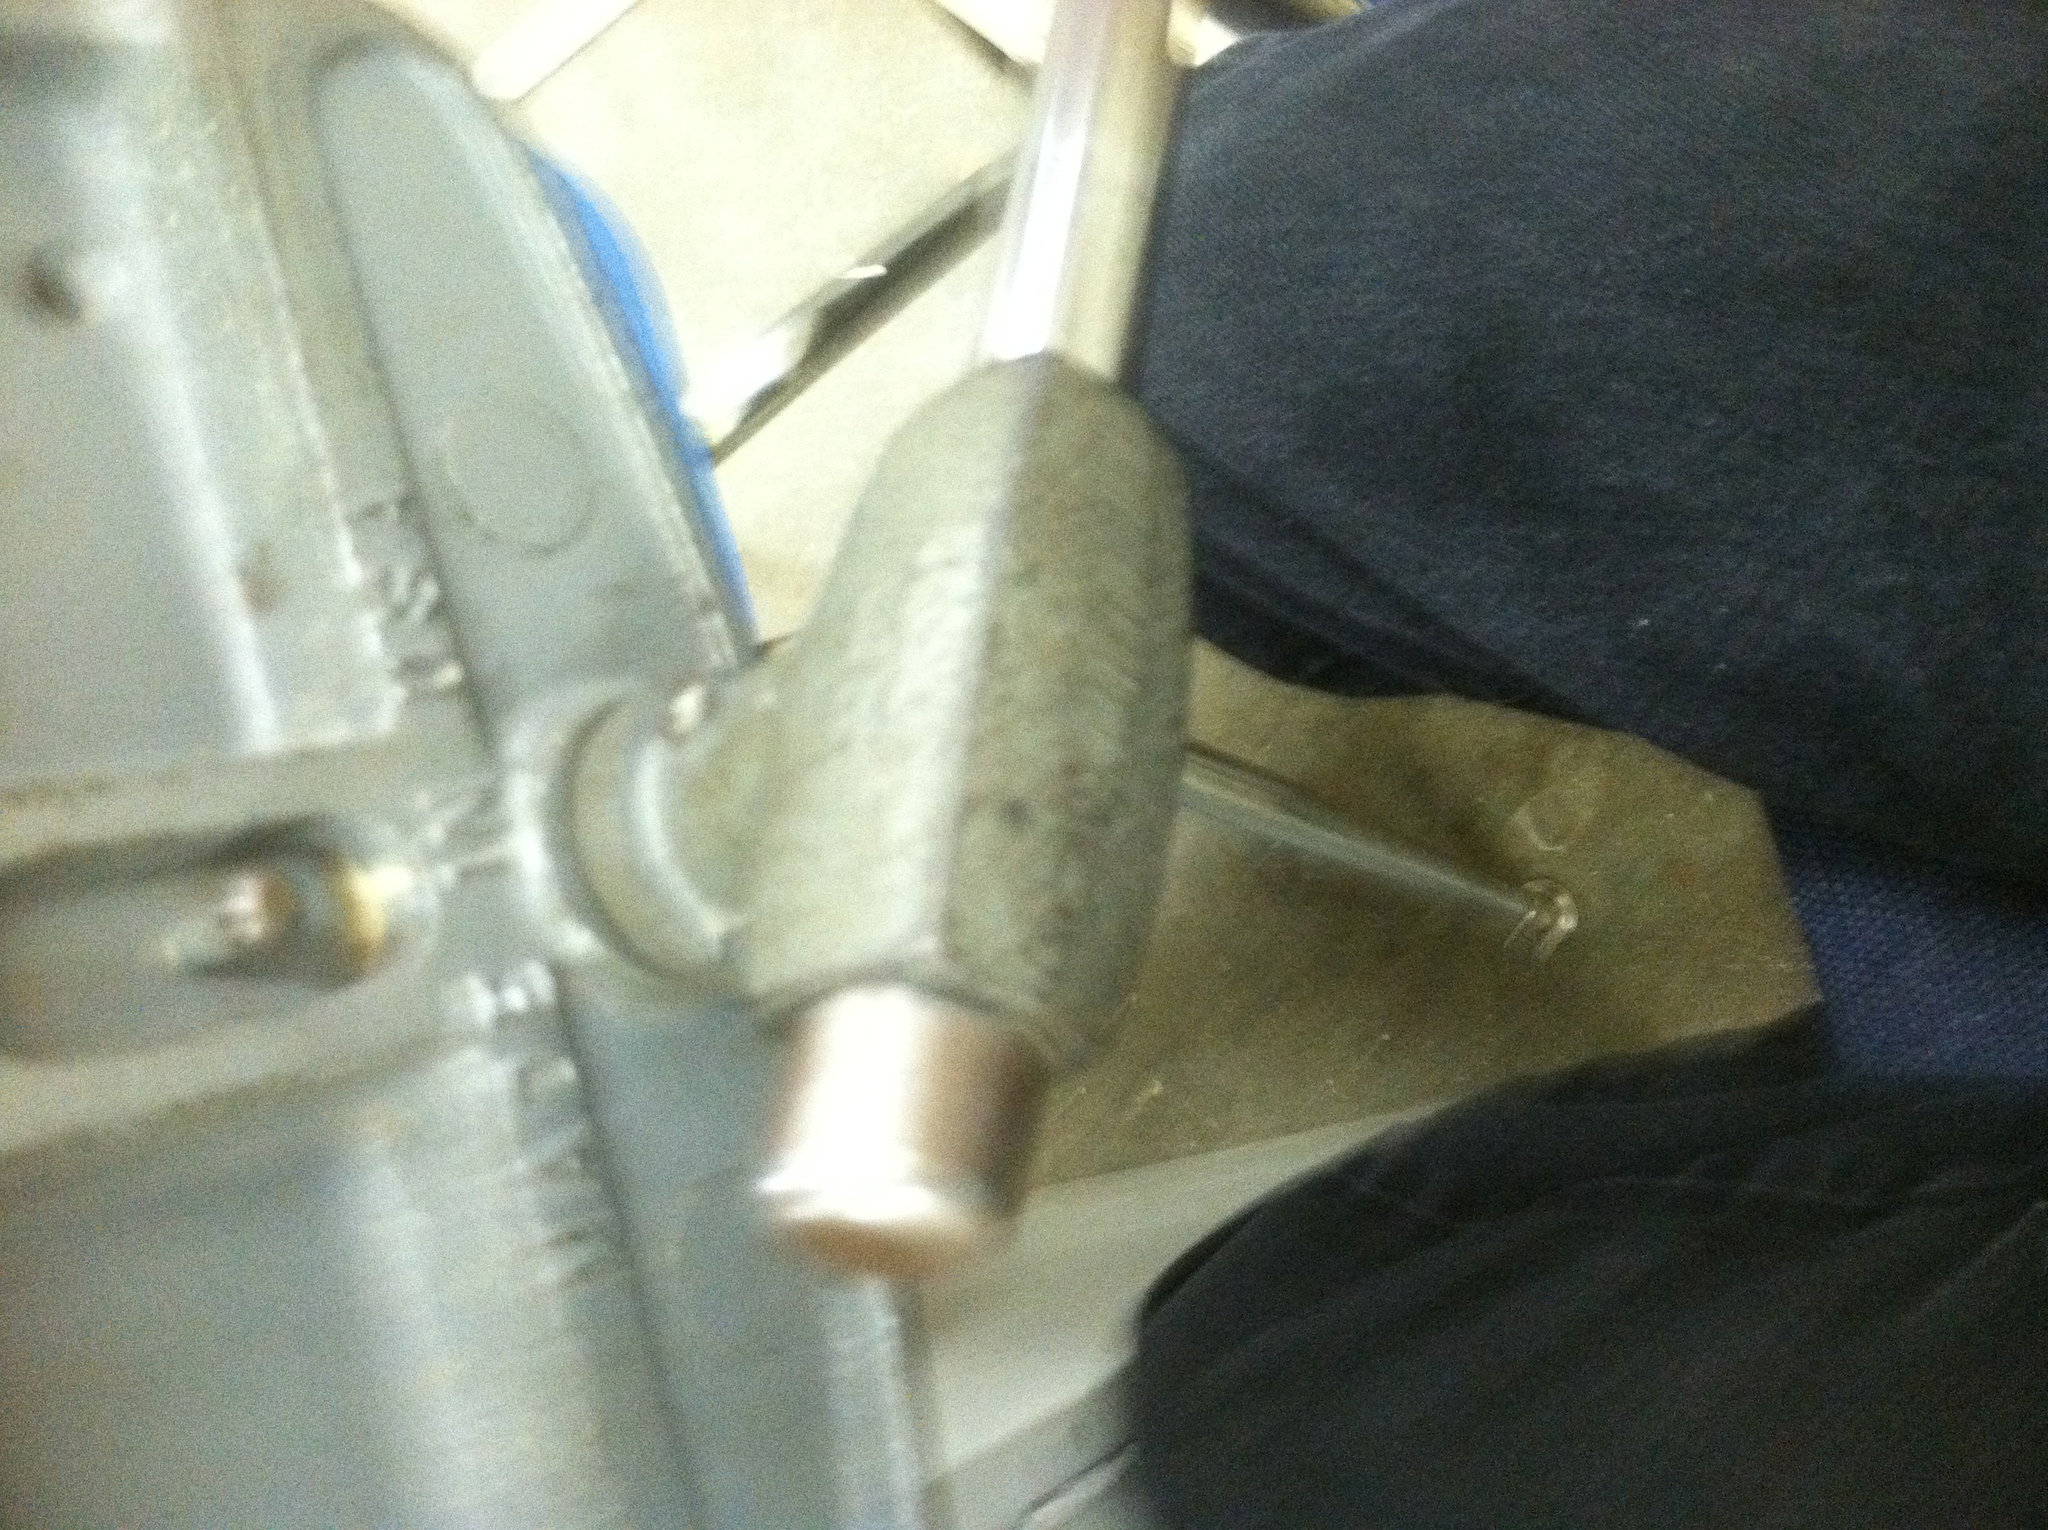What are some common household uses for this tool? In a household setting, a vise can be used for a variety of tasks such as repairing a bicycle, assembling furniture, or crafting projects. It provides a stable and safe way to hold items steady, making it easier to apply force with tools like hammers, saws, or drills. 